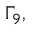<formula> <loc_0><loc_0><loc_500><loc_500>\Gamma _ { 9 } ,</formula> 